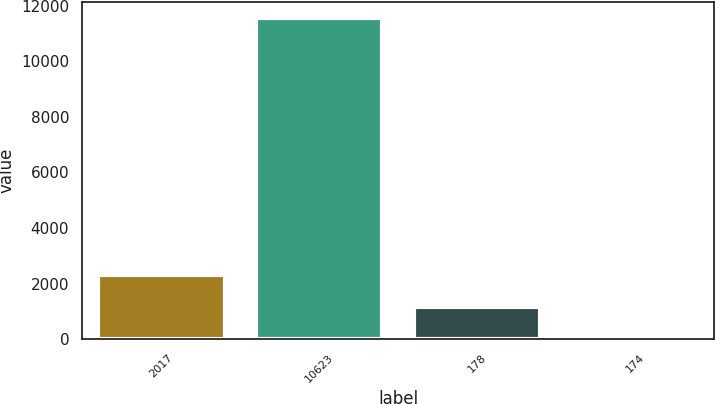Convert chart to OTSL. <chart><loc_0><loc_0><loc_500><loc_500><bar_chart><fcel>2017<fcel>10623<fcel>178<fcel>174<nl><fcel>2313.44<fcel>11562<fcel>1157.37<fcel>1.3<nl></chart> 